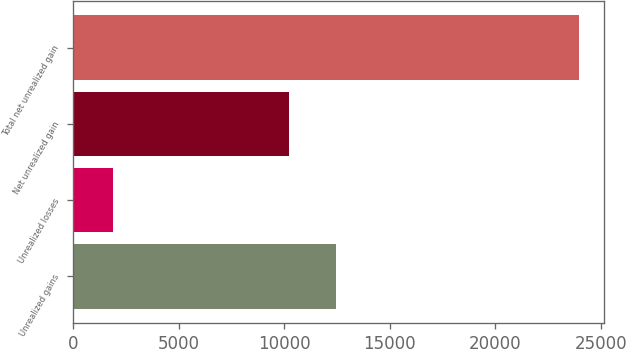Convert chart. <chart><loc_0><loc_0><loc_500><loc_500><bar_chart><fcel>Unrealized gains<fcel>Unrealized losses<fcel>Net unrealized gain<fcel>Total net unrealized gain<nl><fcel>12448.3<fcel>1899<fcel>10243<fcel>23952<nl></chart> 